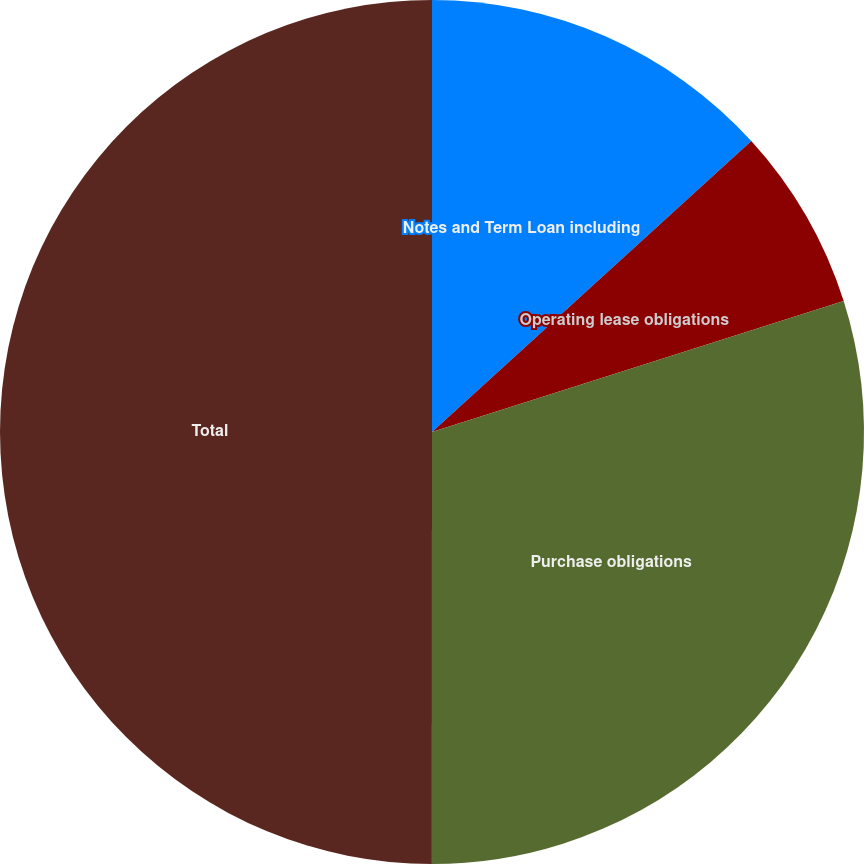<chart> <loc_0><loc_0><loc_500><loc_500><pie_chart><fcel>Notes and Term Loan including<fcel>Operating lease obligations<fcel>Purchase obligations<fcel>Total<nl><fcel>13.24%<fcel>6.86%<fcel>29.91%<fcel>50.0%<nl></chart> 